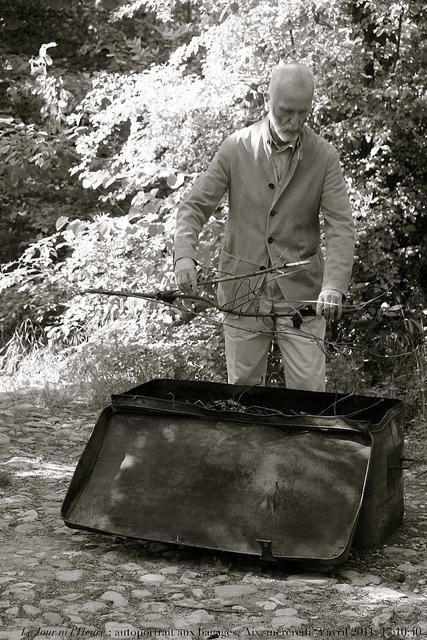Is the man looking up to the sky?
Be succinct. No. Is this picture in color?
Short answer required. No. What is this person holding?
Answer briefly. Stick. 